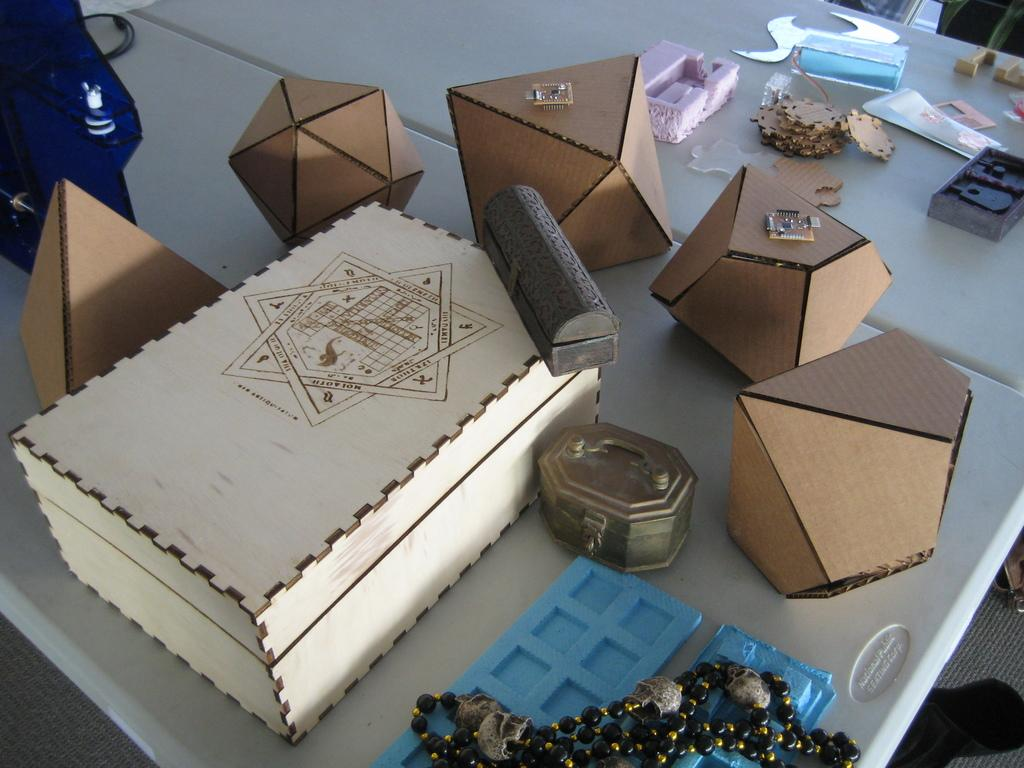What objects are present in the image? There are boxes in the image. Where are the boxes located? The boxes are on a table. What type of fruit is being discussed by the boxes in the image? There is no fruit or discussion present in the image; it only features boxes on a table. 